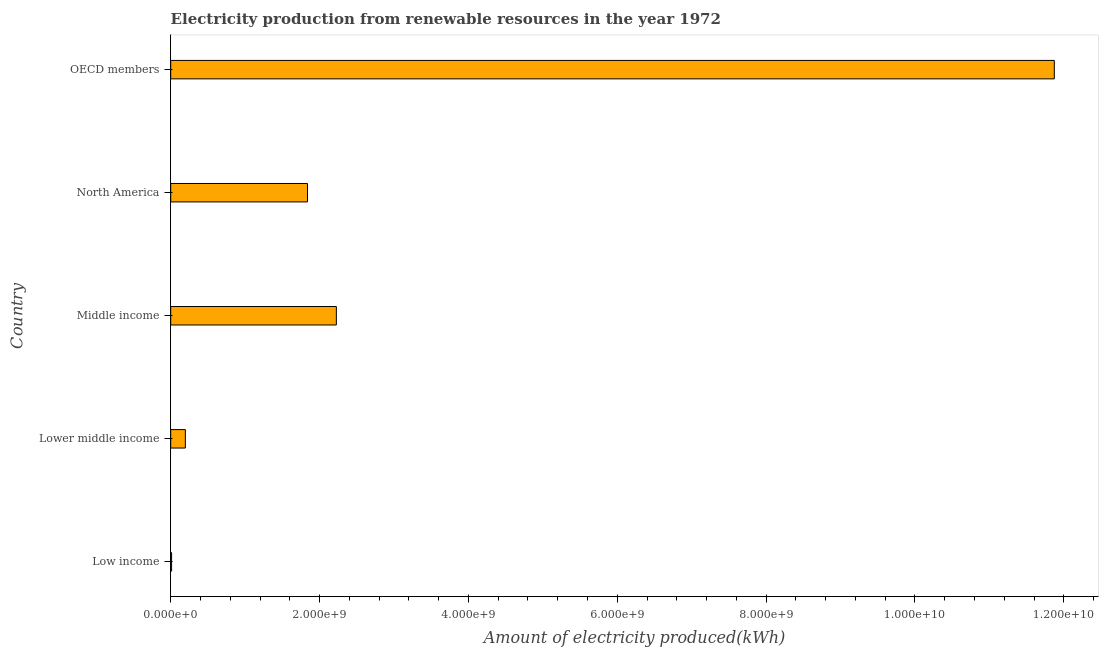What is the title of the graph?
Offer a terse response. Electricity production from renewable resources in the year 1972. What is the label or title of the X-axis?
Ensure brevity in your answer.  Amount of electricity produced(kWh). What is the label or title of the Y-axis?
Keep it short and to the point. Country. What is the amount of electricity produced in OECD members?
Give a very brief answer. 1.19e+1. Across all countries, what is the maximum amount of electricity produced?
Ensure brevity in your answer.  1.19e+1. In which country was the amount of electricity produced maximum?
Keep it short and to the point. OECD members. What is the sum of the amount of electricity produced?
Your answer should be compact. 1.61e+1. What is the difference between the amount of electricity produced in Lower middle income and Middle income?
Your response must be concise. -2.03e+09. What is the average amount of electricity produced per country?
Make the answer very short. 3.23e+09. What is the median amount of electricity produced?
Your response must be concise. 1.84e+09. In how many countries, is the amount of electricity produced greater than 9600000000 kWh?
Offer a terse response. 1. Is the difference between the amount of electricity produced in Lower middle income and Middle income greater than the difference between any two countries?
Provide a short and direct response. No. What is the difference between the highest and the second highest amount of electricity produced?
Offer a very short reply. 9.65e+09. What is the difference between the highest and the lowest amount of electricity produced?
Provide a succinct answer. 1.19e+1. Are all the bars in the graph horizontal?
Your response must be concise. Yes. Are the values on the major ticks of X-axis written in scientific E-notation?
Offer a very short reply. Yes. What is the Amount of electricity produced(kWh) of Lower middle income?
Provide a short and direct response. 1.97e+08. What is the Amount of electricity produced(kWh) of Middle income?
Your answer should be very brief. 2.23e+09. What is the Amount of electricity produced(kWh) in North America?
Your response must be concise. 1.84e+09. What is the Amount of electricity produced(kWh) in OECD members?
Your answer should be compact. 1.19e+1. What is the difference between the Amount of electricity produced(kWh) in Low income and Lower middle income?
Your answer should be compact. -1.85e+08. What is the difference between the Amount of electricity produced(kWh) in Low income and Middle income?
Offer a terse response. -2.21e+09. What is the difference between the Amount of electricity produced(kWh) in Low income and North America?
Your response must be concise. -1.83e+09. What is the difference between the Amount of electricity produced(kWh) in Low income and OECD members?
Keep it short and to the point. -1.19e+1. What is the difference between the Amount of electricity produced(kWh) in Lower middle income and Middle income?
Provide a succinct answer. -2.03e+09. What is the difference between the Amount of electricity produced(kWh) in Lower middle income and North America?
Provide a succinct answer. -1.64e+09. What is the difference between the Amount of electricity produced(kWh) in Lower middle income and OECD members?
Your response must be concise. -1.17e+1. What is the difference between the Amount of electricity produced(kWh) in Middle income and North America?
Your response must be concise. 3.88e+08. What is the difference between the Amount of electricity produced(kWh) in Middle income and OECD members?
Your answer should be very brief. -9.65e+09. What is the difference between the Amount of electricity produced(kWh) in North America and OECD members?
Your answer should be very brief. -1.00e+1. What is the ratio of the Amount of electricity produced(kWh) in Low income to that in Lower middle income?
Your answer should be compact. 0.06. What is the ratio of the Amount of electricity produced(kWh) in Low income to that in Middle income?
Your response must be concise. 0.01. What is the ratio of the Amount of electricity produced(kWh) in Low income to that in North America?
Make the answer very short. 0.01. What is the ratio of the Amount of electricity produced(kWh) in Lower middle income to that in Middle income?
Give a very brief answer. 0.09. What is the ratio of the Amount of electricity produced(kWh) in Lower middle income to that in North America?
Your answer should be compact. 0.11. What is the ratio of the Amount of electricity produced(kWh) in Lower middle income to that in OECD members?
Offer a terse response. 0.02. What is the ratio of the Amount of electricity produced(kWh) in Middle income to that in North America?
Provide a succinct answer. 1.21. What is the ratio of the Amount of electricity produced(kWh) in Middle income to that in OECD members?
Ensure brevity in your answer.  0.19. What is the ratio of the Amount of electricity produced(kWh) in North America to that in OECD members?
Provide a succinct answer. 0.15. 